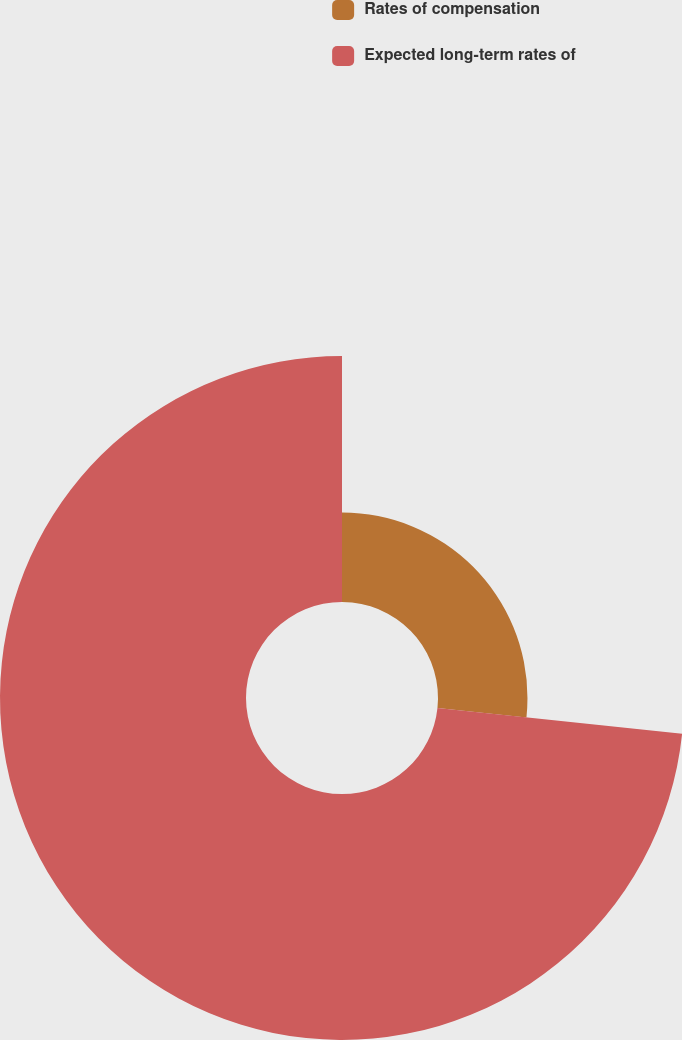Convert chart. <chart><loc_0><loc_0><loc_500><loc_500><pie_chart><fcel>Rates of compensation<fcel>Expected long-term rates of<nl><fcel>26.67%<fcel>73.33%<nl></chart> 